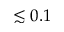<formula> <loc_0><loc_0><loc_500><loc_500>\lesssim 0 . 1</formula> 